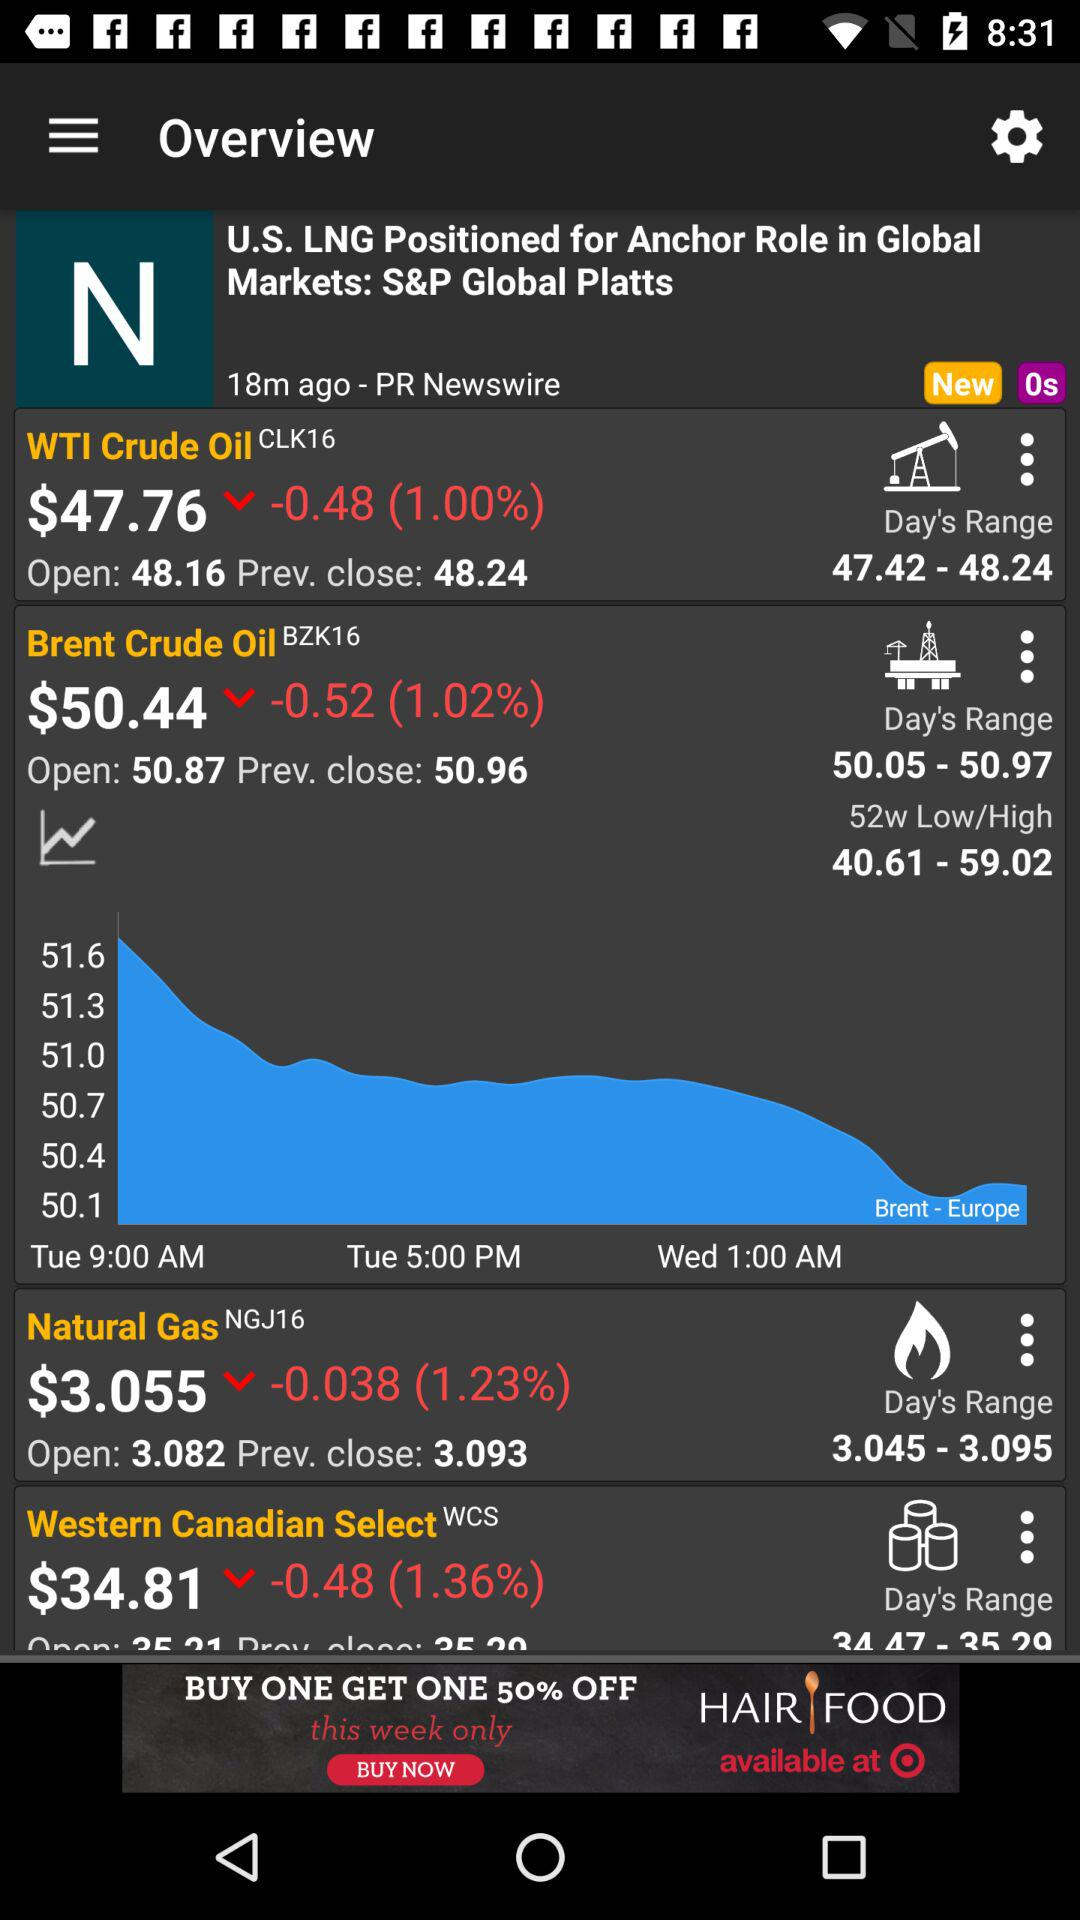What is the difference between the open and closing price of Brent Crude Oil?
Answer the question using a single word or phrase. -0.52 